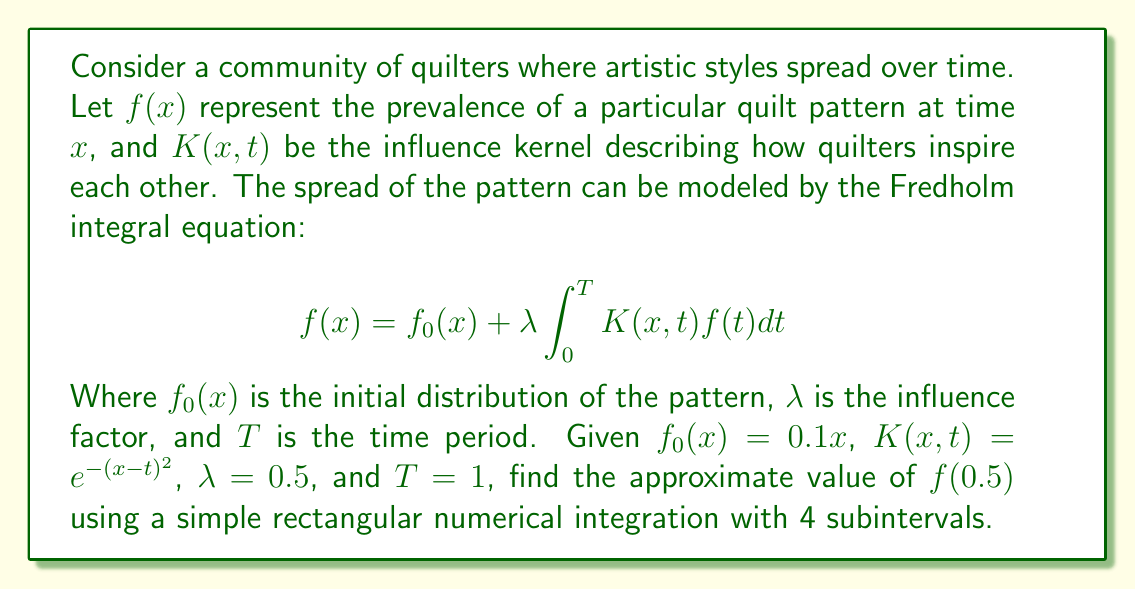Can you solve this math problem? To solve this problem, we'll follow these steps:

1) First, we need to set up the numerical integration. We'll divide the interval [0,1] into 4 subintervals:
   $[0, 0.25], [0.25, 0.5], [0.5, 0.75], [0.75, 1]$

2) The midpoints of these intervals are:
   $t_1 = 0.125, t_2 = 0.375, t_3 = 0.625, t_4 = 0.875$

3) We'll use the rectangular rule: $\int_0^1 g(t)dt \approx \sum_{i=1}^4 g(t_i) \Delta t$
   where $\Delta t = 0.25$

4) Our integral equation for $f(0.5)$ becomes:

   $$f(0.5) = f_0(0.5) + 0.5 \sum_{i=1}^4 K(0.5,t_i)f(t_i) \cdot 0.25$$

5) We need to approximate $f(t_i)$ for each $i$. We'll use $f_0(t_i)$ as an initial approximation:

   $f(t_1) \approx f_0(0.125) = 0.1 \cdot 0.125 = 0.0125$
   $f(t_2) \approx f_0(0.375) = 0.1 \cdot 0.375 = 0.0375$
   $f(t_3) \approx f_0(0.625) = 0.1 \cdot 0.625 = 0.0625$
   $f(t_4) \approx f_0(0.875) = 0.1 \cdot 0.875 = 0.0875$

6) Now, let's calculate $K(0.5,t_i)$ for each $i$:

   $K(0.5,t_1) = e^{-(0.5-0.125)^2} = e^{-0.140625} \approx 0.8687$
   $K(0.5,t_2) = e^{-(0.5-0.375)^2} = e^{-0.015625} \approx 0.9845$
   $K(0.5,t_3) = e^{-(0.5-0.625)^2} = e^{-0.015625} \approx 0.9845$
   $K(0.5,t_4) = e^{-(0.5-0.875)^2} = e^{-0.140625} \approx 0.8687$

7) Now we can calculate:

   $$\begin{align*}
   f(0.5) &= f_0(0.5) + 0.5 \sum_{i=1}^4 K(0.5,t_i)f(t_i) \cdot 0.25 \\
   &= 0.1 \cdot 0.5 + 0.5 \cdot 0.25 \cdot (0.8687 \cdot 0.0125 + 0.9845 \cdot 0.0375 + 0.9845 \cdot 0.0625 + 0.8687 \cdot 0.0875) \\
   &= 0.05 + 0.125 \cdot (0.010859 + 0.036919 + 0.061531 + 0.076011) \\
   &= 0.05 + 0.125 \cdot 0.18532 \\
   &= 0.05 + 0.023165 \\
   &= 0.073165
   \end{align*}$$
Answer: $f(0.5) \approx 0.073165$ 